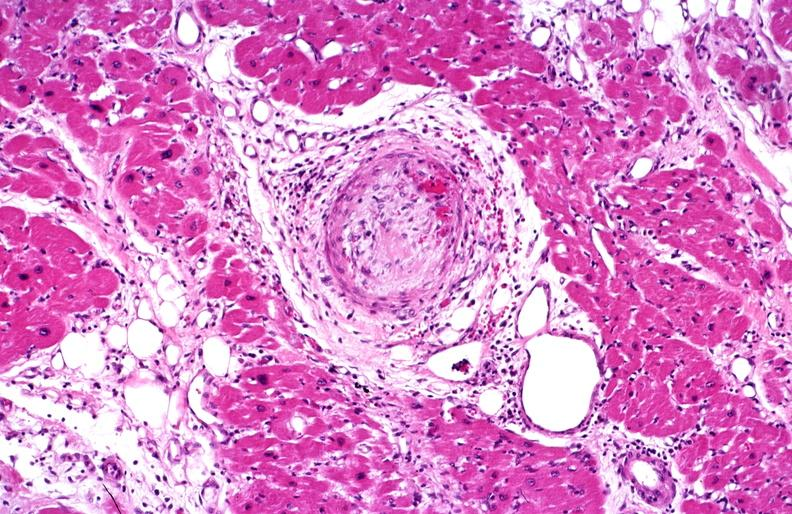what does this image show?
Answer the question using a single word or phrase. Heart 